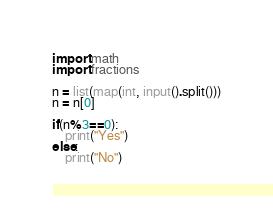Convert code to text. <code><loc_0><loc_0><loc_500><loc_500><_Python_>import math
import fractions

n = list(map(int, input().split()))
n = n[0]

if(n%3==0):
    print("Yes")
else:
    print("No")</code> 